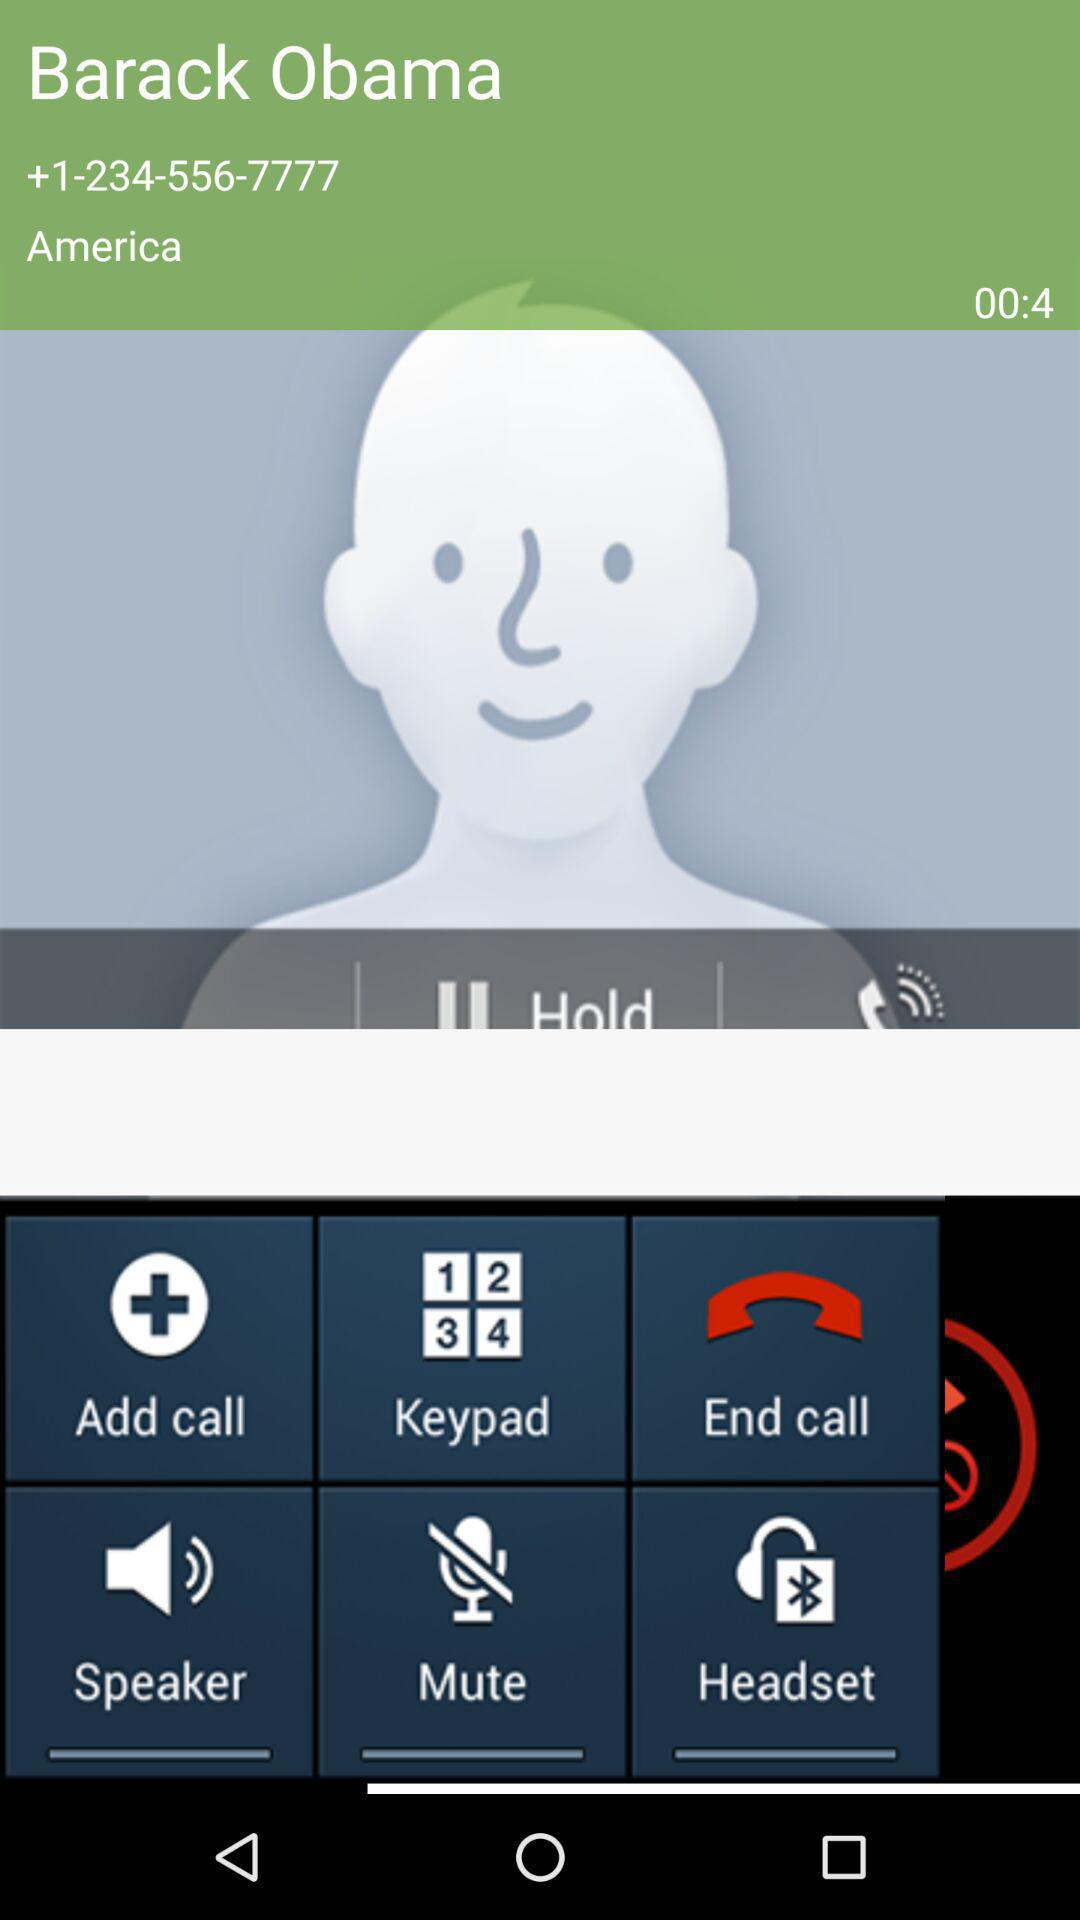What is the current status of the call?
When the provided information is insufficient, respond with <no answer>. <no answer> 